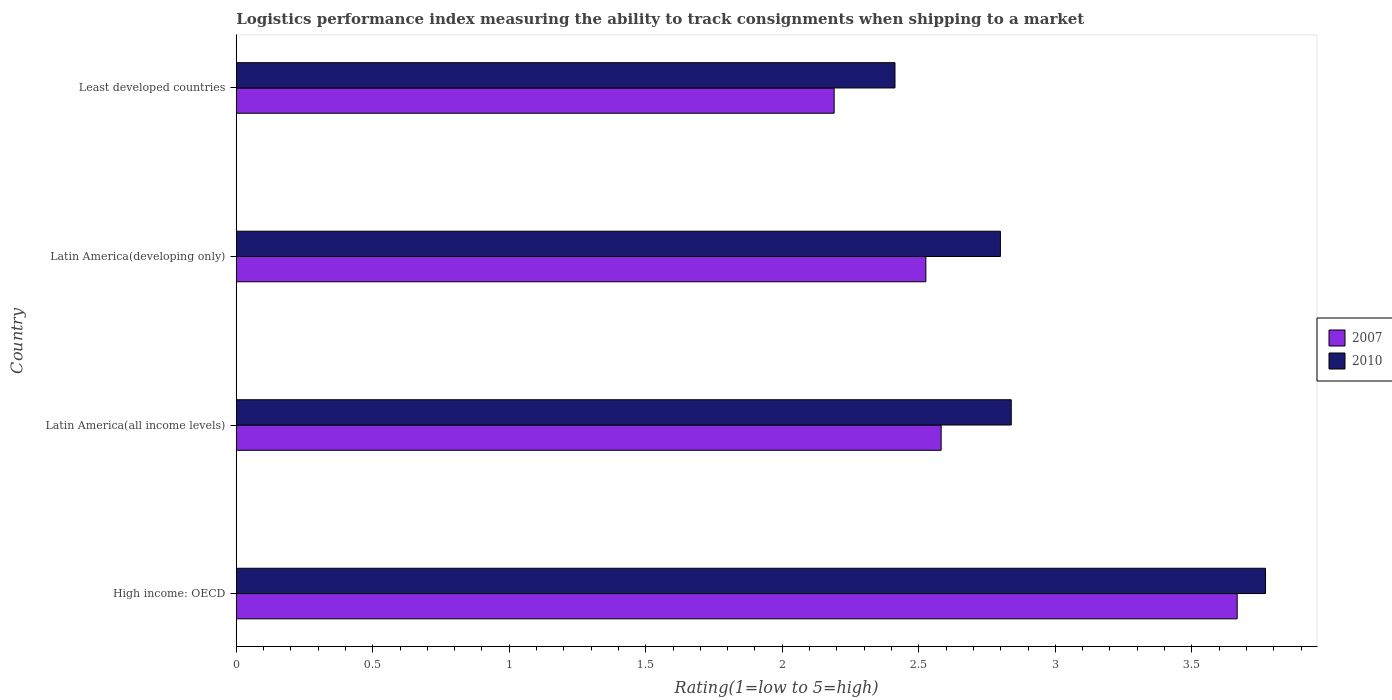Are the number of bars per tick equal to the number of legend labels?
Give a very brief answer. Yes. Are the number of bars on each tick of the Y-axis equal?
Your response must be concise. Yes. How many bars are there on the 2nd tick from the top?
Your response must be concise. 2. How many bars are there on the 1st tick from the bottom?
Your response must be concise. 2. What is the label of the 1st group of bars from the top?
Give a very brief answer. Least developed countries. What is the Logistic performance index in 2010 in Least developed countries?
Your answer should be compact. 2.41. Across all countries, what is the maximum Logistic performance index in 2007?
Your response must be concise. 3.67. Across all countries, what is the minimum Logistic performance index in 2007?
Ensure brevity in your answer.  2.19. In which country was the Logistic performance index in 2007 maximum?
Your answer should be compact. High income: OECD. In which country was the Logistic performance index in 2010 minimum?
Offer a terse response. Least developed countries. What is the total Logistic performance index in 2010 in the graph?
Keep it short and to the point. 11.82. What is the difference between the Logistic performance index in 2010 in High income: OECD and that in Latin America(all income levels)?
Offer a terse response. 0.93. What is the difference between the Logistic performance index in 2007 in Least developed countries and the Logistic performance index in 2010 in Latin America(all income levels)?
Keep it short and to the point. -0.65. What is the average Logistic performance index in 2007 per country?
Keep it short and to the point. 2.74. What is the difference between the Logistic performance index in 2007 and Logistic performance index in 2010 in Latin America(all income levels)?
Provide a short and direct response. -0.26. In how many countries, is the Logistic performance index in 2007 greater than 2.3 ?
Offer a very short reply. 3. What is the ratio of the Logistic performance index in 2007 in High income: OECD to that in Least developed countries?
Your response must be concise. 1.67. Is the difference between the Logistic performance index in 2007 in Latin America(all income levels) and Least developed countries greater than the difference between the Logistic performance index in 2010 in Latin America(all income levels) and Least developed countries?
Provide a short and direct response. No. What is the difference between the highest and the second highest Logistic performance index in 2007?
Give a very brief answer. 1.08. What is the difference between the highest and the lowest Logistic performance index in 2007?
Keep it short and to the point. 1.48. In how many countries, is the Logistic performance index in 2010 greater than the average Logistic performance index in 2010 taken over all countries?
Make the answer very short. 1. What does the 1st bar from the top in High income: OECD represents?
Your answer should be very brief. 2010. How many countries are there in the graph?
Your answer should be very brief. 4. What is the difference between two consecutive major ticks on the X-axis?
Make the answer very short. 0.5. Does the graph contain any zero values?
Your answer should be compact. No. Does the graph contain grids?
Offer a terse response. No. What is the title of the graph?
Provide a short and direct response. Logistics performance index measuring the ability to track consignments when shipping to a market. What is the label or title of the X-axis?
Offer a very short reply. Rating(1=low to 5=high). What is the Rating(1=low to 5=high) of 2007 in High income: OECD?
Ensure brevity in your answer.  3.67. What is the Rating(1=low to 5=high) in 2010 in High income: OECD?
Your answer should be very brief. 3.77. What is the Rating(1=low to 5=high) in 2007 in Latin America(all income levels)?
Provide a short and direct response. 2.58. What is the Rating(1=low to 5=high) of 2010 in Latin America(all income levels)?
Your answer should be compact. 2.84. What is the Rating(1=low to 5=high) of 2007 in Latin America(developing only)?
Keep it short and to the point. 2.53. What is the Rating(1=low to 5=high) in 2010 in Latin America(developing only)?
Keep it short and to the point. 2.8. What is the Rating(1=low to 5=high) in 2007 in Least developed countries?
Offer a terse response. 2.19. What is the Rating(1=low to 5=high) in 2010 in Least developed countries?
Make the answer very short. 2.41. Across all countries, what is the maximum Rating(1=low to 5=high) of 2007?
Ensure brevity in your answer.  3.67. Across all countries, what is the maximum Rating(1=low to 5=high) in 2010?
Your answer should be very brief. 3.77. Across all countries, what is the minimum Rating(1=low to 5=high) of 2007?
Keep it short and to the point. 2.19. Across all countries, what is the minimum Rating(1=low to 5=high) of 2010?
Your response must be concise. 2.41. What is the total Rating(1=low to 5=high) in 2007 in the graph?
Offer a terse response. 10.96. What is the total Rating(1=low to 5=high) of 2010 in the graph?
Your answer should be very brief. 11.82. What is the difference between the Rating(1=low to 5=high) of 2007 in High income: OECD and that in Latin America(all income levels)?
Your response must be concise. 1.08. What is the difference between the Rating(1=low to 5=high) of 2010 in High income: OECD and that in Latin America(all income levels)?
Offer a terse response. 0.93. What is the difference between the Rating(1=low to 5=high) of 2007 in High income: OECD and that in Latin America(developing only)?
Provide a short and direct response. 1.14. What is the difference between the Rating(1=low to 5=high) of 2010 in High income: OECD and that in Latin America(developing only)?
Offer a terse response. 0.97. What is the difference between the Rating(1=low to 5=high) of 2007 in High income: OECD and that in Least developed countries?
Your answer should be compact. 1.48. What is the difference between the Rating(1=low to 5=high) in 2010 in High income: OECD and that in Least developed countries?
Your response must be concise. 1.36. What is the difference between the Rating(1=low to 5=high) in 2007 in Latin America(all income levels) and that in Latin America(developing only)?
Your answer should be compact. 0.06. What is the difference between the Rating(1=low to 5=high) in 2010 in Latin America(all income levels) and that in Latin America(developing only)?
Give a very brief answer. 0.04. What is the difference between the Rating(1=low to 5=high) in 2007 in Latin America(all income levels) and that in Least developed countries?
Offer a terse response. 0.39. What is the difference between the Rating(1=low to 5=high) in 2010 in Latin America(all income levels) and that in Least developed countries?
Your response must be concise. 0.43. What is the difference between the Rating(1=low to 5=high) of 2007 in Latin America(developing only) and that in Least developed countries?
Ensure brevity in your answer.  0.34. What is the difference between the Rating(1=low to 5=high) in 2010 in Latin America(developing only) and that in Least developed countries?
Keep it short and to the point. 0.39. What is the difference between the Rating(1=low to 5=high) in 2007 in High income: OECD and the Rating(1=low to 5=high) in 2010 in Latin America(all income levels)?
Your answer should be compact. 0.83. What is the difference between the Rating(1=low to 5=high) in 2007 in High income: OECD and the Rating(1=low to 5=high) in 2010 in Latin America(developing only)?
Provide a succinct answer. 0.87. What is the difference between the Rating(1=low to 5=high) of 2007 in High income: OECD and the Rating(1=low to 5=high) of 2010 in Least developed countries?
Provide a short and direct response. 1.25. What is the difference between the Rating(1=low to 5=high) of 2007 in Latin America(all income levels) and the Rating(1=low to 5=high) of 2010 in Latin America(developing only)?
Keep it short and to the point. -0.22. What is the difference between the Rating(1=low to 5=high) of 2007 in Latin America(all income levels) and the Rating(1=low to 5=high) of 2010 in Least developed countries?
Give a very brief answer. 0.17. What is the difference between the Rating(1=low to 5=high) in 2007 in Latin America(developing only) and the Rating(1=low to 5=high) in 2010 in Least developed countries?
Give a very brief answer. 0.11. What is the average Rating(1=low to 5=high) of 2007 per country?
Give a very brief answer. 2.74. What is the average Rating(1=low to 5=high) in 2010 per country?
Provide a succinct answer. 2.96. What is the difference between the Rating(1=low to 5=high) in 2007 and Rating(1=low to 5=high) in 2010 in High income: OECD?
Your response must be concise. -0.1. What is the difference between the Rating(1=low to 5=high) in 2007 and Rating(1=low to 5=high) in 2010 in Latin America(all income levels)?
Make the answer very short. -0.26. What is the difference between the Rating(1=low to 5=high) of 2007 and Rating(1=low to 5=high) of 2010 in Latin America(developing only)?
Keep it short and to the point. -0.27. What is the difference between the Rating(1=low to 5=high) of 2007 and Rating(1=low to 5=high) of 2010 in Least developed countries?
Make the answer very short. -0.22. What is the ratio of the Rating(1=low to 5=high) of 2007 in High income: OECD to that in Latin America(all income levels)?
Offer a very short reply. 1.42. What is the ratio of the Rating(1=low to 5=high) of 2010 in High income: OECD to that in Latin America(all income levels)?
Make the answer very short. 1.33. What is the ratio of the Rating(1=low to 5=high) of 2007 in High income: OECD to that in Latin America(developing only)?
Offer a terse response. 1.45. What is the ratio of the Rating(1=low to 5=high) in 2010 in High income: OECD to that in Latin America(developing only)?
Offer a terse response. 1.35. What is the ratio of the Rating(1=low to 5=high) of 2007 in High income: OECD to that in Least developed countries?
Keep it short and to the point. 1.67. What is the ratio of the Rating(1=low to 5=high) in 2010 in High income: OECD to that in Least developed countries?
Your answer should be very brief. 1.56. What is the ratio of the Rating(1=low to 5=high) in 2007 in Latin America(all income levels) to that in Latin America(developing only)?
Your response must be concise. 1.02. What is the ratio of the Rating(1=low to 5=high) of 2010 in Latin America(all income levels) to that in Latin America(developing only)?
Give a very brief answer. 1.01. What is the ratio of the Rating(1=low to 5=high) of 2007 in Latin America(all income levels) to that in Least developed countries?
Provide a short and direct response. 1.18. What is the ratio of the Rating(1=low to 5=high) in 2010 in Latin America(all income levels) to that in Least developed countries?
Offer a very short reply. 1.18. What is the ratio of the Rating(1=low to 5=high) of 2007 in Latin America(developing only) to that in Least developed countries?
Provide a short and direct response. 1.15. What is the ratio of the Rating(1=low to 5=high) of 2010 in Latin America(developing only) to that in Least developed countries?
Give a very brief answer. 1.16. What is the difference between the highest and the second highest Rating(1=low to 5=high) in 2007?
Ensure brevity in your answer.  1.08. What is the difference between the highest and the second highest Rating(1=low to 5=high) of 2010?
Keep it short and to the point. 0.93. What is the difference between the highest and the lowest Rating(1=low to 5=high) in 2007?
Provide a short and direct response. 1.48. What is the difference between the highest and the lowest Rating(1=low to 5=high) of 2010?
Keep it short and to the point. 1.36. 